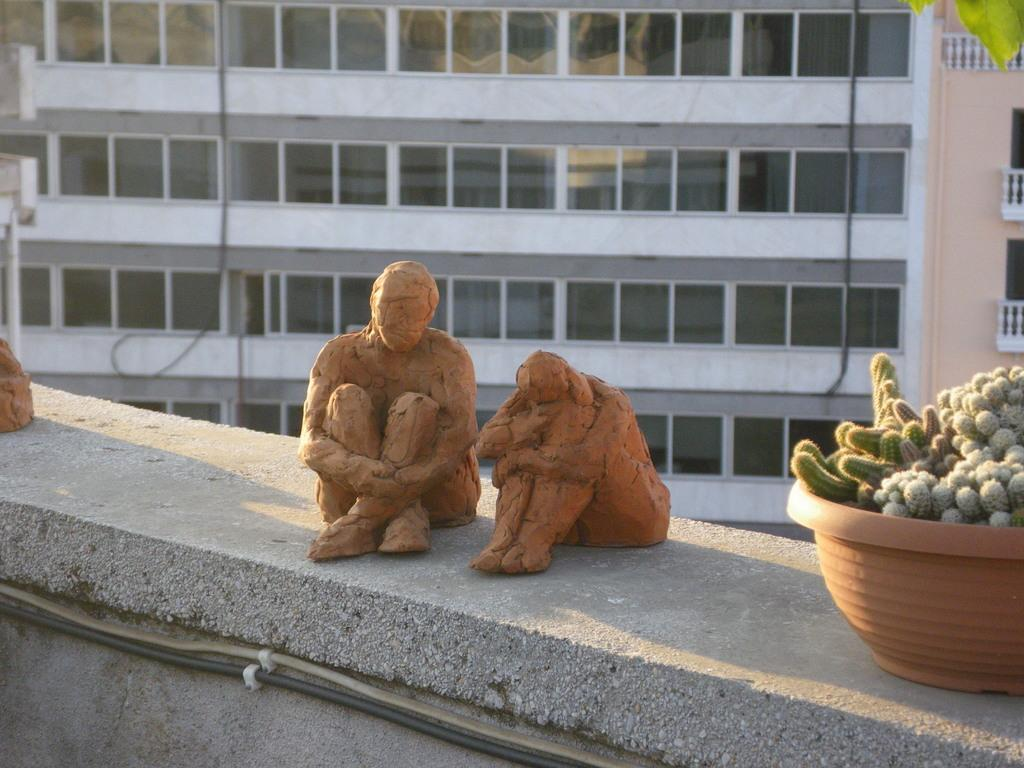What type of objects can be seen in the image? There are statues in the image. Are there any living organisms present in the image? Yes, there is a plant in the image. What can be seen in the background of the image? There is a building and glasses in the background of the image. What school is the actor attending in the image? There is no school or actor present in the image. What type of mark can be seen on the statue's forehead in the image? There is no mark visible on the statues' foreheads in the image. 